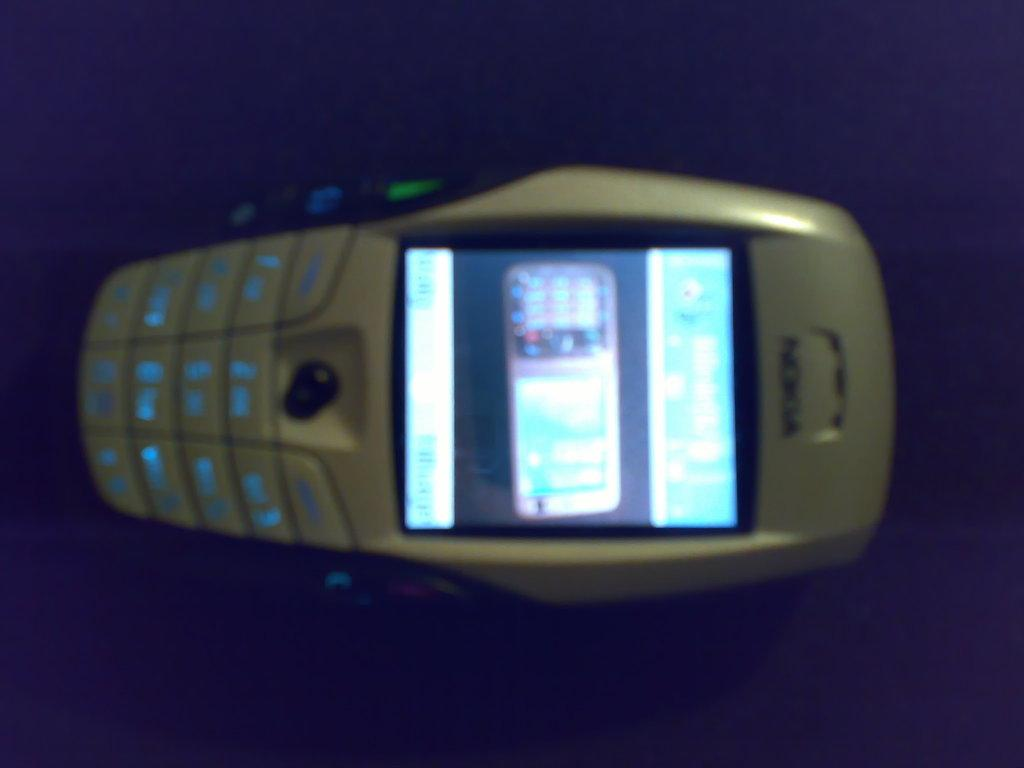What type of mobile is visible in the image? There is a white Nokia mobile in the image. What features does the mobile have? The mobile has buttons and a display screen. What is the color of the background in the image? The background of the image is dark. What book is the person reading in the image? There is no person or book visible in the image; it only features a white Nokia mobile. What type of competition is taking place in the image? There is no competition present in the image; it only features a white Nokia mobile. 